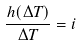<formula> <loc_0><loc_0><loc_500><loc_500>\frac { h ( \Delta T ) } { \Delta T } = i</formula> 